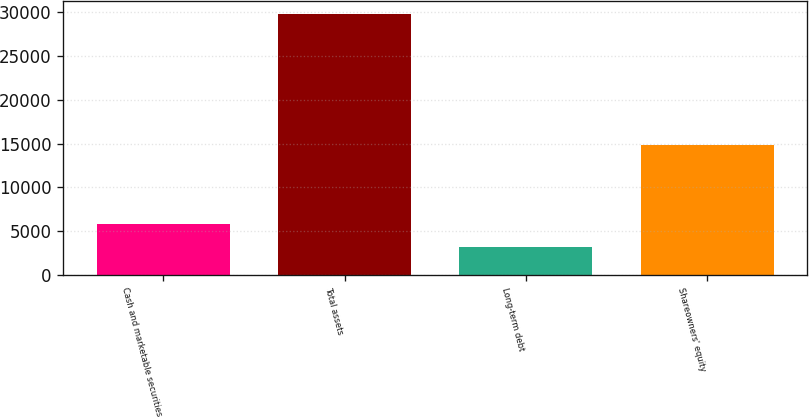<chart> <loc_0><loc_0><loc_500><loc_500><bar_chart><fcel>Cash and marketable securities<fcel>Total assets<fcel>Long-term debt<fcel>Shareowners' equity<nl><fcel>5807.5<fcel>29734<fcel>3149<fcel>14852<nl></chart> 